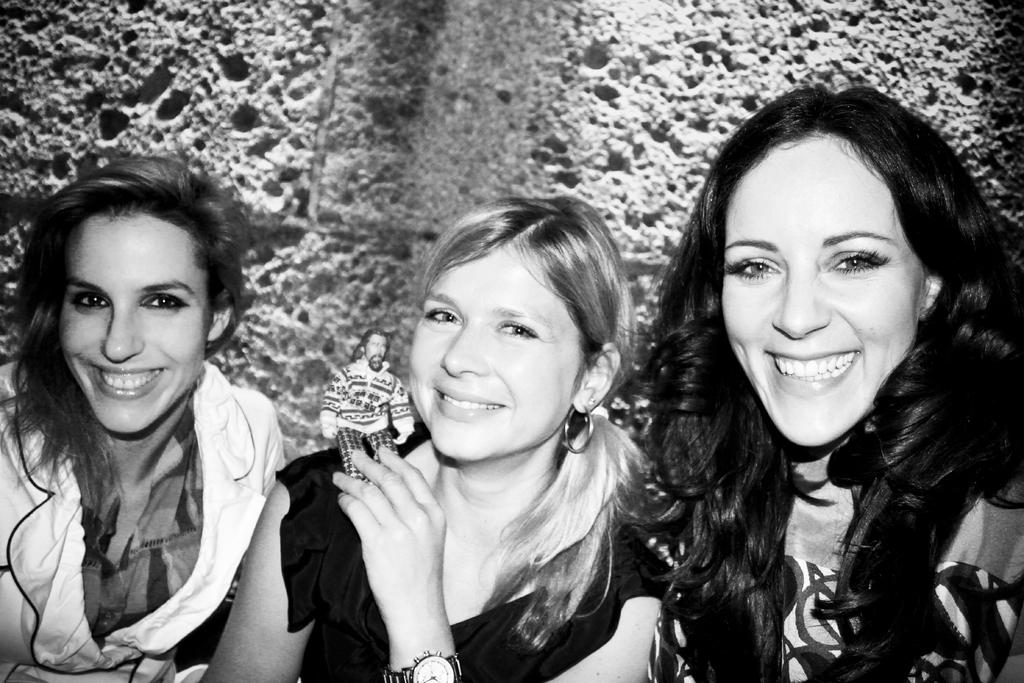How many people are in the image? There are two persons sitting and smiling in the image. What are the people in the image doing? They are sitting and smiling. Is there anyone holding an object in the image? Yes, there is a person sitting and smiling while holding a toy in the image. What can be seen in the background of the image? There is a wall in the background of the image. What type of seed is being planted by the farmer in the image? There is no farmer or seed present in the image. 